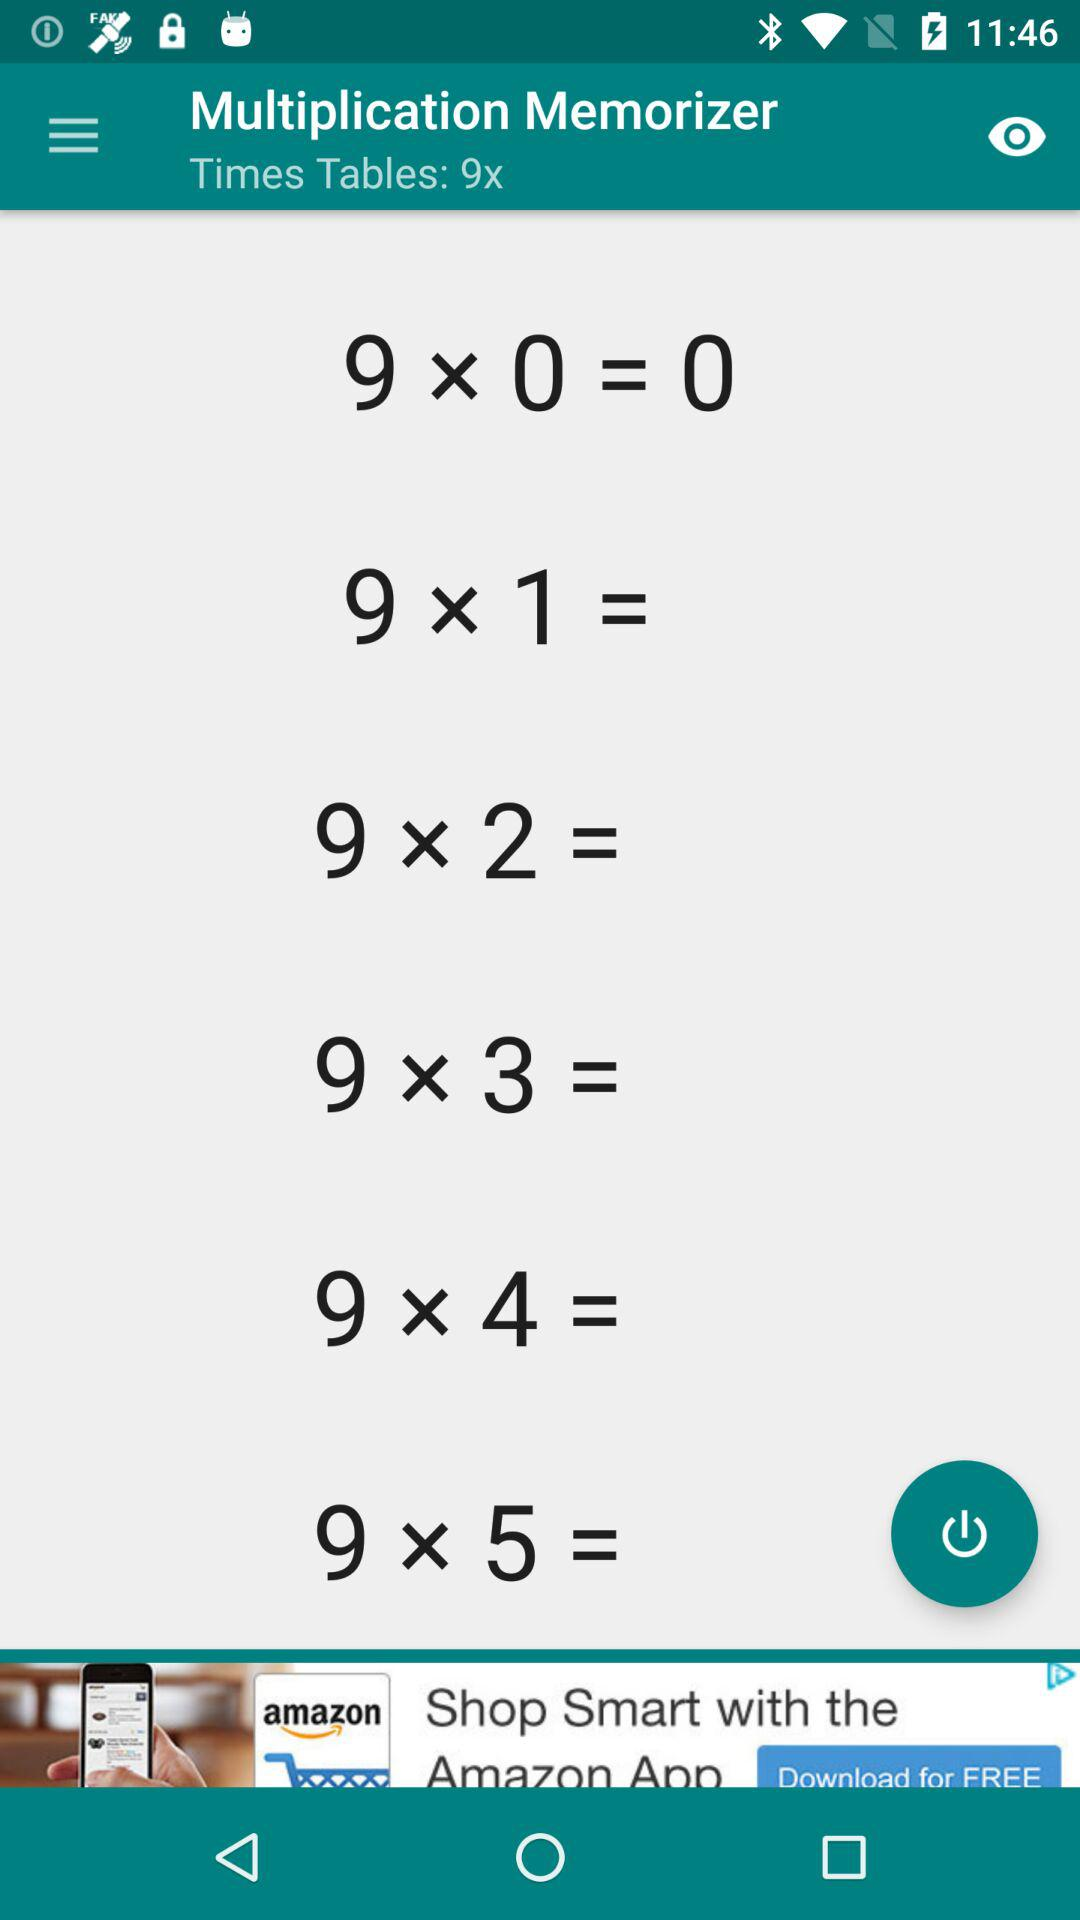What are the "Times Tables"? "Time Tables" are "9x". 